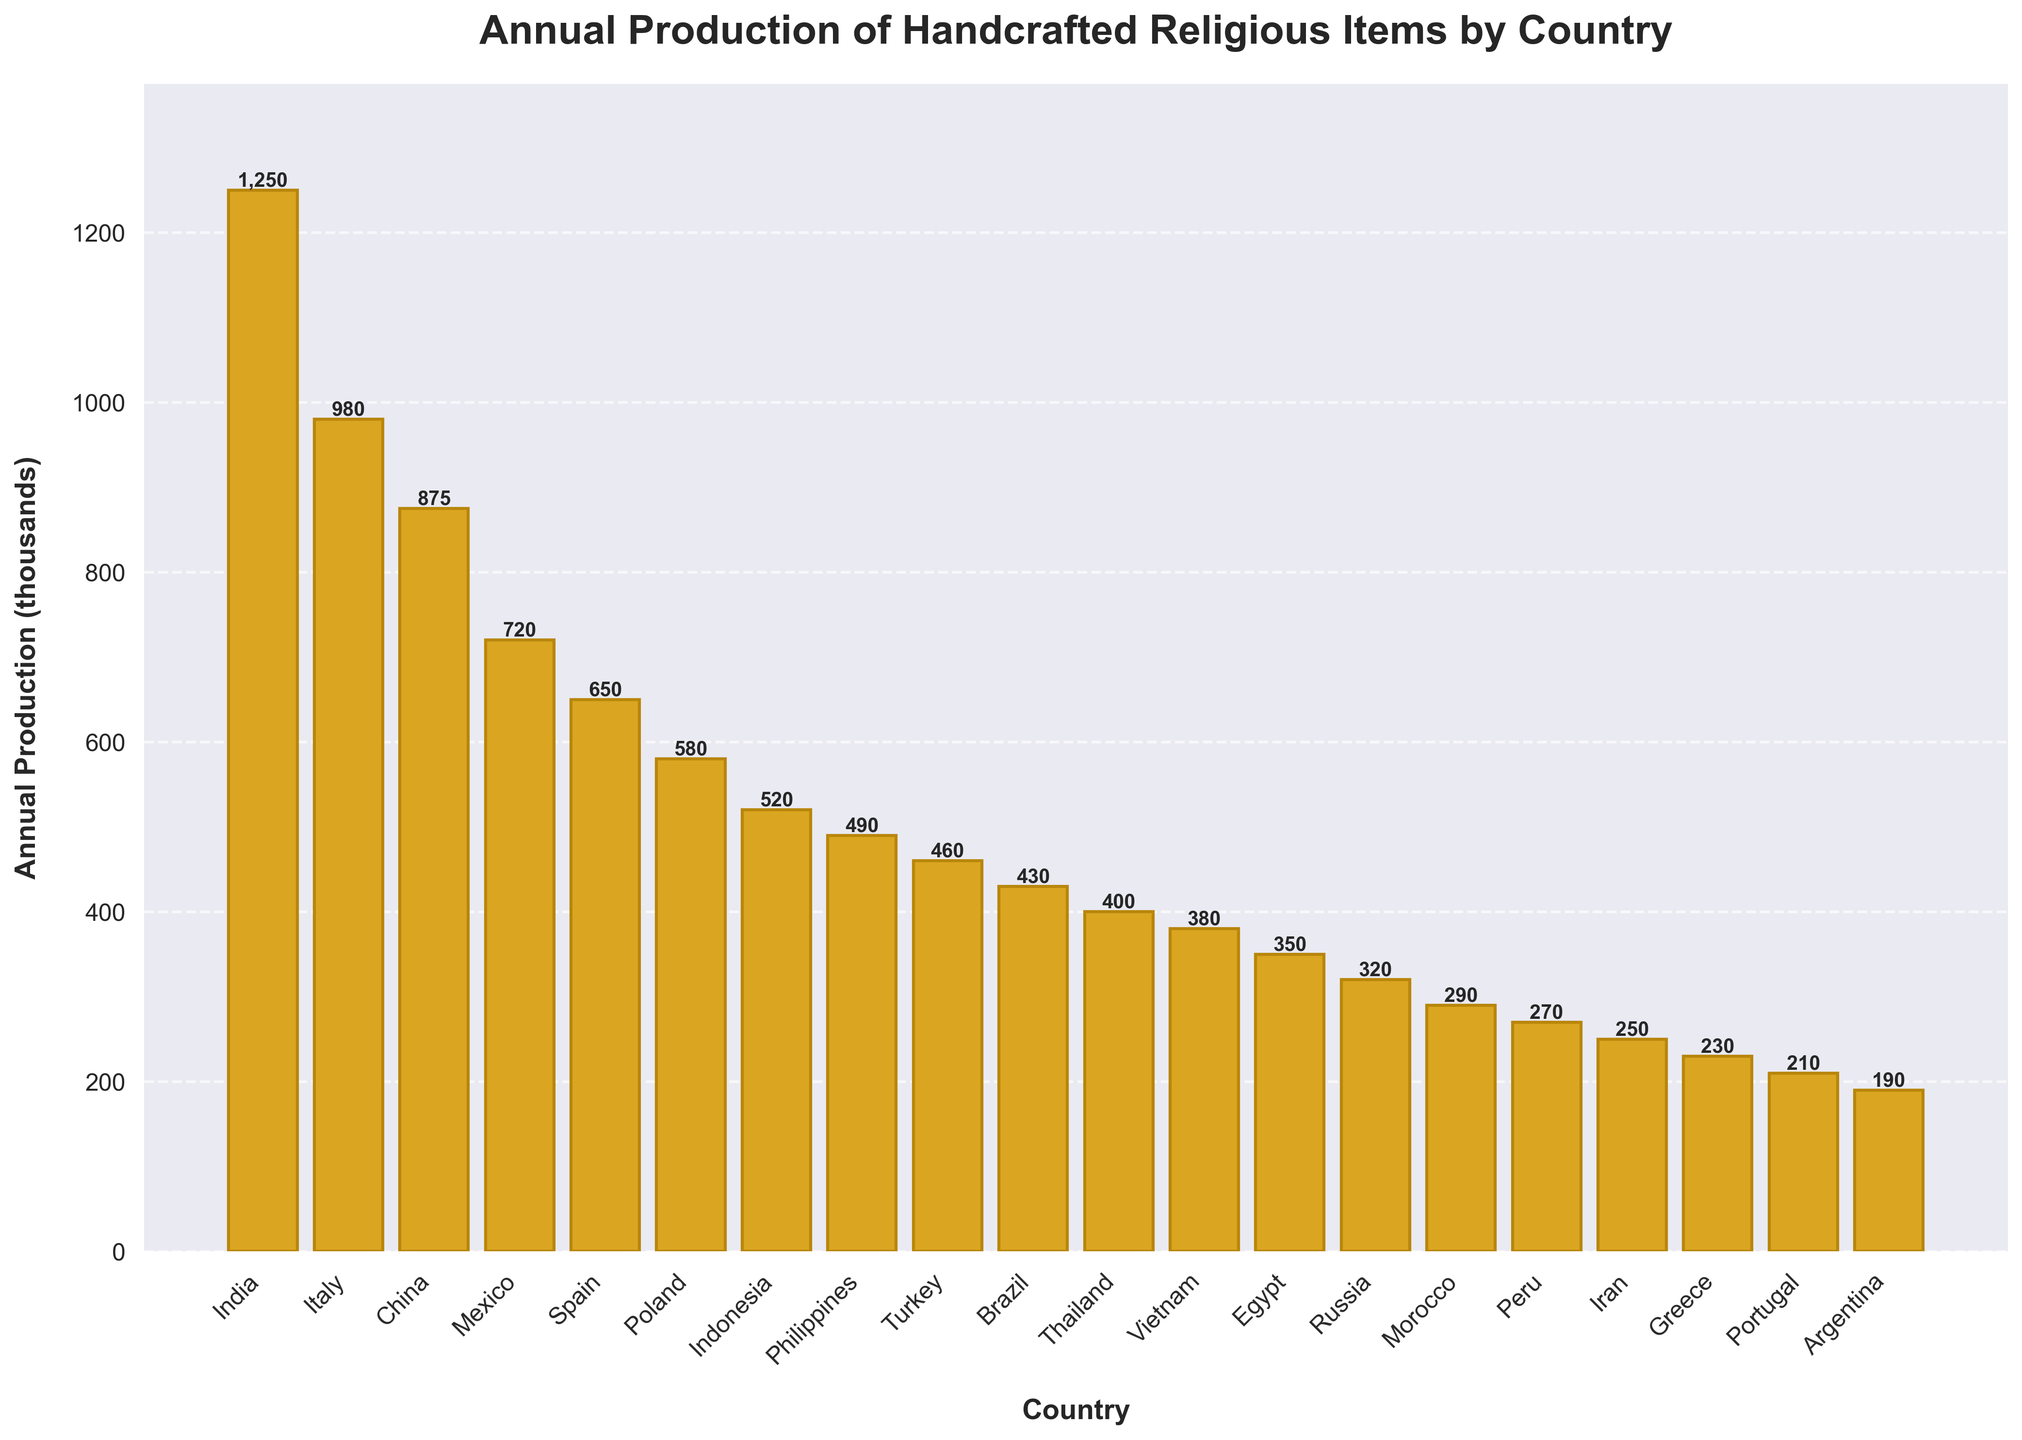Which country has the highest annual production of handcrafted religious items? The bar for India is the tallest, reaching the highest value on the y-axis, which represents the annual production.
Answer: India Which country has the lowest annual production of handcrafted religious items? The bar for Argentina is the shortest, reaching the lowest value on the y-axis, which represents the annual production.
Answer: Argentina What is the total annual production of the top three countries combined? The top three countries, based on the height of the bars, are India, Italy, and China. Their production values are 1250, 980, and 875 thousands, respectively. Combining them: 1250 + 980 + 875 = 3105.
Answer: 3105 How much more is India's production compared to Brazil's production? India's production is 1250 thousands, and Brazil's production is 430 thousands. The difference is 1250 - 430 = 820.
Answer: 820 Is the combined production of Mexico and Spain greater than Italy's production? The combined production of Mexico and Spain is 720 + 650 = 1370. Italy’s production is 980. Since 1370 > 980, the combined production of Mexico and Spain is greater.
Answer: Yes What is the average annual production of handcrafted religious items for the bottom five countries? The bottom five countries are Argentina, Portugal, Greece, Iran, and Peru. Their production values are 190, 210, 230, 250, and 270 thousands, respectively. The sum is 190 + 210 + 230 + 250 + 270 = 1150. The average is 1150 / 5 = 230.
Answer: 230 What is the production difference between the country ranked fifth and the country ranked fifteenth? The fifth country is Spain with 650 thousands and the fifteenth country is Morocco with 290 thousands. The difference is 650 - 290 = 360.
Answer: 360 Which countries have production values greater than 500 but less than 1000 thousands? By visually inspecting the bars, the countries within this range are Italy (980), China (875), Mexico (720), and Spain (650).
Answer: Italy, China, Mexico, Spain If the production of handcrafted items in Indonesia doubles, what will its new value be, and will it surpass Italy? Indonesia’s current production is 520 thousands. Doubling this value: 520 * 2 = 1040. Italy’s production is 980 thousands, so 1040 > 980. With the new value, Indonesia will surpass Italy.
Answer: Yes, 1040 How many countries have an annual production less than 400 thousand items? The countries fitting this criterion are Thailand (400), Vietnam (380), Egypt (350), Russia (320), Morocco (290), Peru (270), Iran (250), Greece (230), Portugal (210), and Argentina (190). Counting them, there are 10 countries.
Answer: 10 